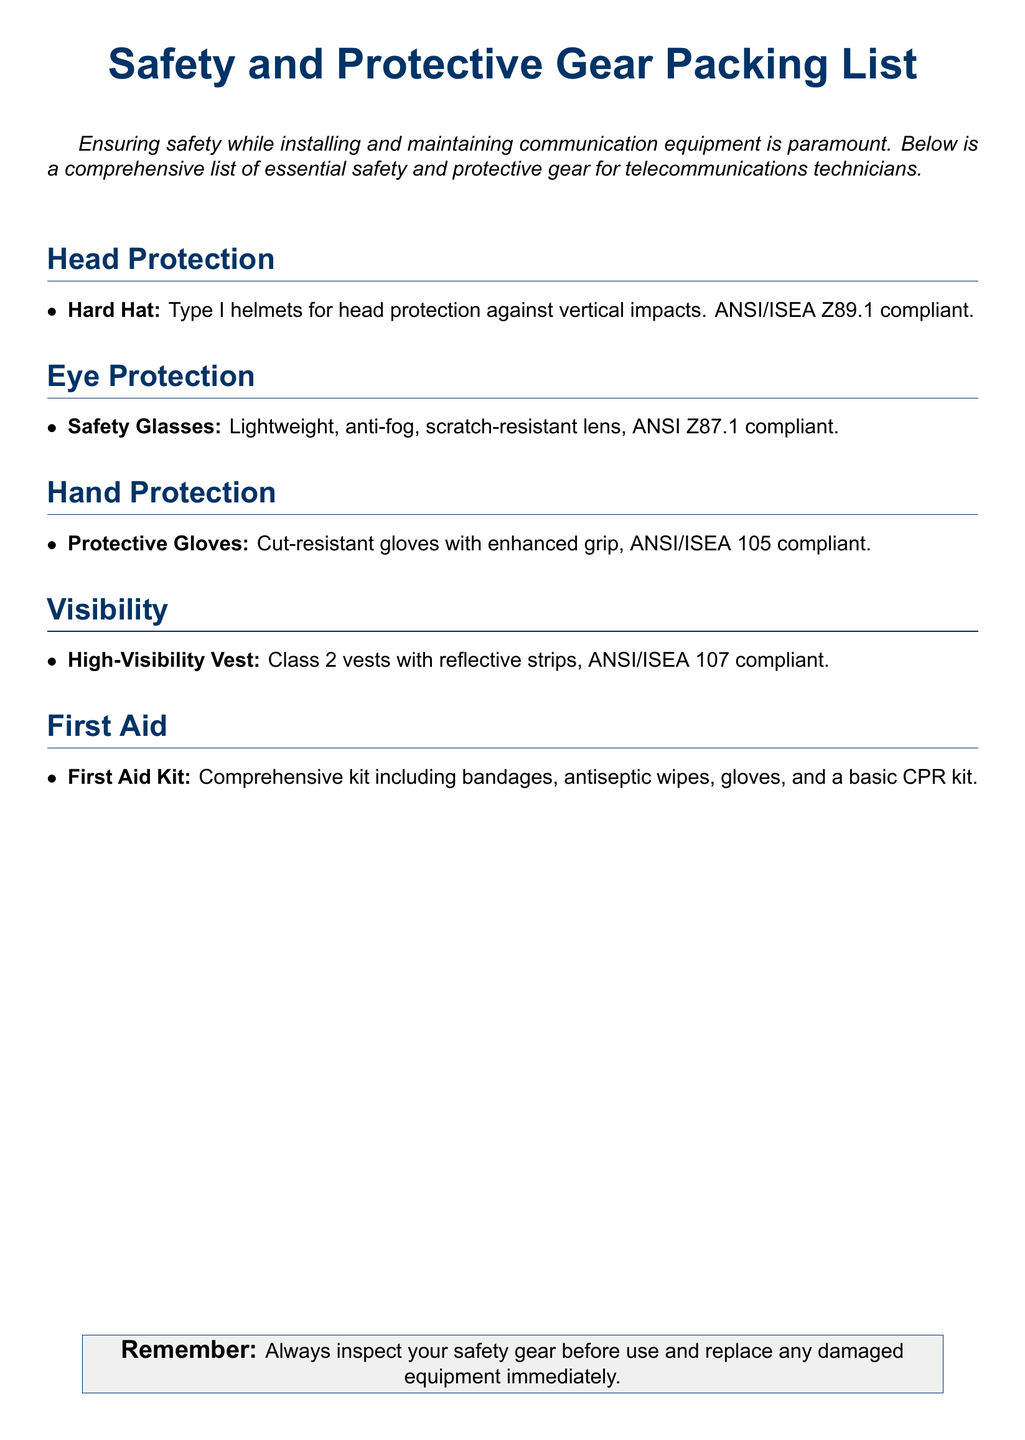What is the type of helmets specified? The document specifies Type I helmets for head protection.
Answer: Type I What standard do the safety glasses meet? The safety glasses are ANSI Z87.1 compliant.
Answer: ANSI Z87.1 What feature do the gloves have? The gloves are cut-resistant with enhanced grip.
Answer: Cut-resistant What class are the high-visibility vests? The vests are classified as Class 2.
Answer: Class 2 What is included in the first aid kit? The kit includes bandages, antiseptic wipes, gloves, and a basic CPR kit.
Answer: Bandages, antiseptic wipes, gloves, basic CPR kit How should safety gear be treated before use? Safety gear should be inspected before use.
Answer: Inspected Which ANSI/ISEA standard is mentioned for hard hats? Hard hats must comply with ANSI/ISEA Z89.1.
Answer: ANSI/ISEA Z89.1 What does the packing list emphasize about safety gear? It emphasizes the importance of replacing damaged equipment immediately.
Answer: Replace damaged equipment immediately 